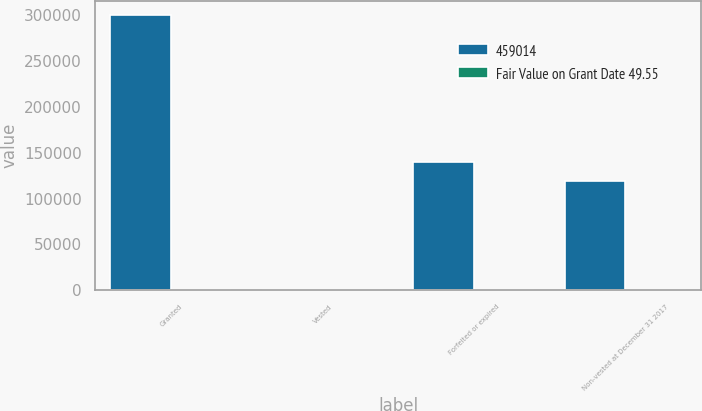Convert chart. <chart><loc_0><loc_0><loc_500><loc_500><stacked_bar_chart><ecel><fcel>Granted<fcel>Vested<fcel>Forfeited or expired<fcel>Non-vested at December 31 2017<nl><fcel>459014<fcel>300002<fcel>48.4<fcel>139605<fcel>118956<nl><fcel>Fair Value on Grant Date 49.55<fcel>44.88<fcel>47.89<fcel>46.43<fcel>48.4<nl></chart> 